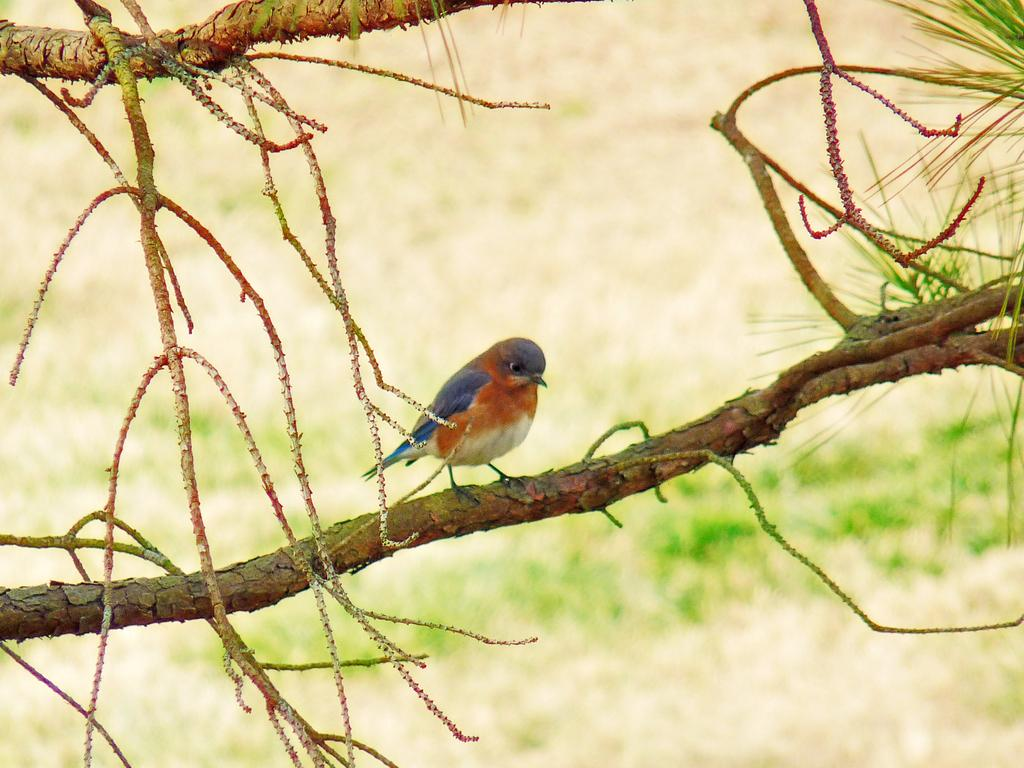What type of animal is present in the image? There is a bird in the image. Where is the bird located? The bird is on a tree. Can you describe the position of the bird and tree in the image? The bird and tree are in the center of the image. What type of mitten is the bird holding in the image? There is no mitten present in the image; it features a bird on a tree. What type of cloth is draped over the tree in the image? There is no cloth draped over the tree in the image; it only features a bird on a tree. 